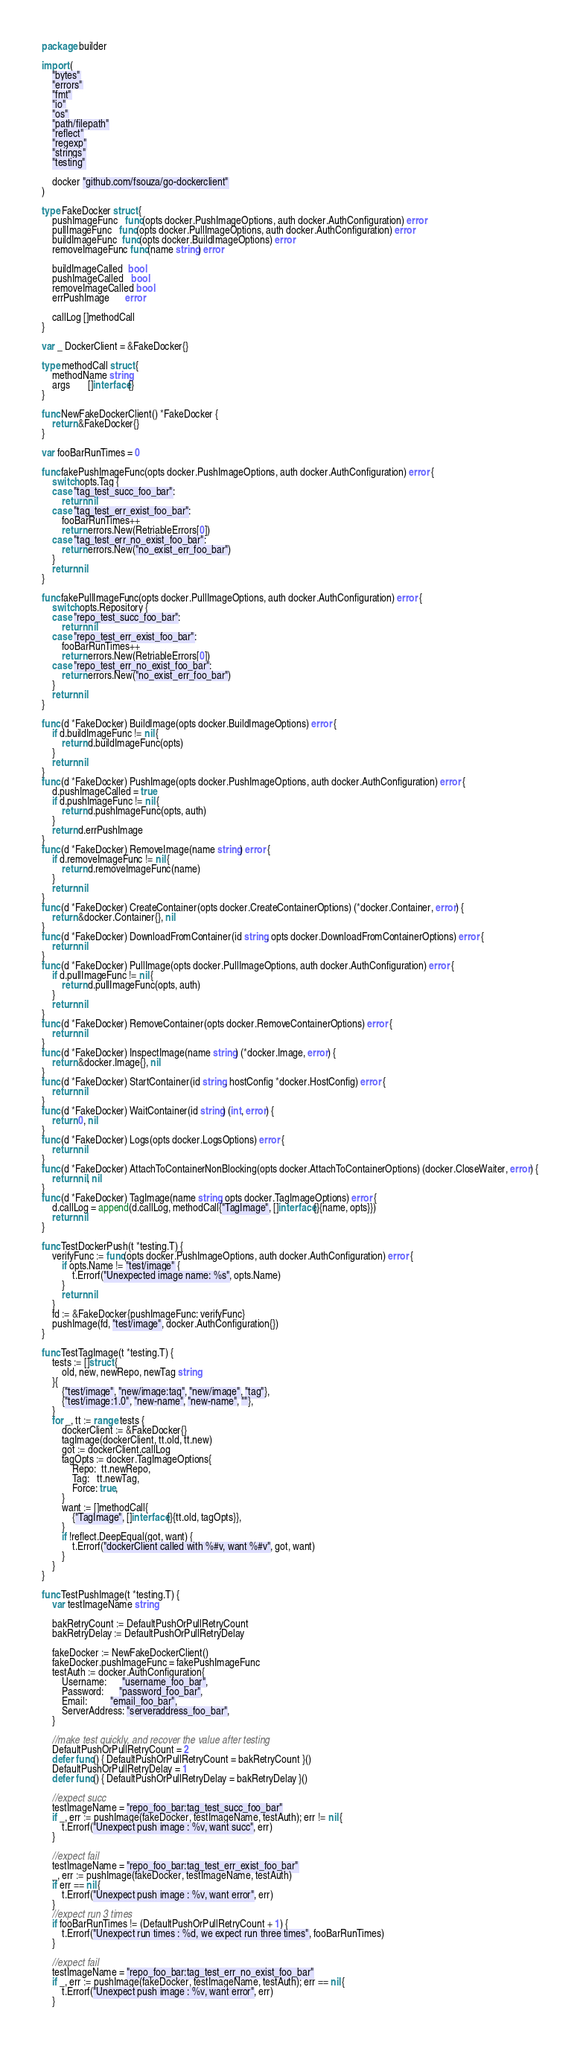Convert code to text. <code><loc_0><loc_0><loc_500><loc_500><_Go_>package builder

import (
	"bytes"
	"errors"
	"fmt"
	"io"
	"os"
	"path/filepath"
	"reflect"
	"regexp"
	"strings"
	"testing"

	docker "github.com/fsouza/go-dockerclient"
)

type FakeDocker struct {
	pushImageFunc   func(opts docker.PushImageOptions, auth docker.AuthConfiguration) error
	pullImageFunc   func(opts docker.PullImageOptions, auth docker.AuthConfiguration) error
	buildImageFunc  func(opts docker.BuildImageOptions) error
	removeImageFunc func(name string) error

	buildImageCalled  bool
	pushImageCalled   bool
	removeImageCalled bool
	errPushImage      error

	callLog []methodCall
}

var _ DockerClient = &FakeDocker{}

type methodCall struct {
	methodName string
	args       []interface{}
}

func NewFakeDockerClient() *FakeDocker {
	return &FakeDocker{}
}

var fooBarRunTimes = 0

func fakePushImageFunc(opts docker.PushImageOptions, auth docker.AuthConfiguration) error {
	switch opts.Tag {
	case "tag_test_succ_foo_bar":
		return nil
	case "tag_test_err_exist_foo_bar":
		fooBarRunTimes++
		return errors.New(RetriableErrors[0])
	case "tag_test_err_no_exist_foo_bar":
		return errors.New("no_exist_err_foo_bar")
	}
	return nil
}

func fakePullImageFunc(opts docker.PullImageOptions, auth docker.AuthConfiguration) error {
	switch opts.Repository {
	case "repo_test_succ_foo_bar":
		return nil
	case "repo_test_err_exist_foo_bar":
		fooBarRunTimes++
		return errors.New(RetriableErrors[0])
	case "repo_test_err_no_exist_foo_bar":
		return errors.New("no_exist_err_foo_bar")
	}
	return nil
}

func (d *FakeDocker) BuildImage(opts docker.BuildImageOptions) error {
	if d.buildImageFunc != nil {
		return d.buildImageFunc(opts)
	}
	return nil
}
func (d *FakeDocker) PushImage(opts docker.PushImageOptions, auth docker.AuthConfiguration) error {
	d.pushImageCalled = true
	if d.pushImageFunc != nil {
		return d.pushImageFunc(opts, auth)
	}
	return d.errPushImage
}
func (d *FakeDocker) RemoveImage(name string) error {
	if d.removeImageFunc != nil {
		return d.removeImageFunc(name)
	}
	return nil
}
func (d *FakeDocker) CreateContainer(opts docker.CreateContainerOptions) (*docker.Container, error) {
	return &docker.Container{}, nil
}
func (d *FakeDocker) DownloadFromContainer(id string, opts docker.DownloadFromContainerOptions) error {
	return nil
}
func (d *FakeDocker) PullImage(opts docker.PullImageOptions, auth docker.AuthConfiguration) error {
	if d.pullImageFunc != nil {
		return d.pullImageFunc(opts, auth)
	}
	return nil
}
func (d *FakeDocker) RemoveContainer(opts docker.RemoveContainerOptions) error {
	return nil
}
func (d *FakeDocker) InspectImage(name string) (*docker.Image, error) {
	return &docker.Image{}, nil
}
func (d *FakeDocker) StartContainer(id string, hostConfig *docker.HostConfig) error {
	return nil
}
func (d *FakeDocker) WaitContainer(id string) (int, error) {
	return 0, nil
}
func (d *FakeDocker) Logs(opts docker.LogsOptions) error {
	return nil
}
func (d *FakeDocker) AttachToContainerNonBlocking(opts docker.AttachToContainerOptions) (docker.CloseWaiter, error) {
	return nil, nil
}
func (d *FakeDocker) TagImage(name string, opts docker.TagImageOptions) error {
	d.callLog = append(d.callLog, methodCall{"TagImage", []interface{}{name, opts}})
	return nil
}

func TestDockerPush(t *testing.T) {
	verifyFunc := func(opts docker.PushImageOptions, auth docker.AuthConfiguration) error {
		if opts.Name != "test/image" {
			t.Errorf("Unexpected image name: %s", opts.Name)
		}
		return nil
	}
	fd := &FakeDocker{pushImageFunc: verifyFunc}
	pushImage(fd, "test/image", docker.AuthConfiguration{})
}

func TestTagImage(t *testing.T) {
	tests := []struct {
		old, new, newRepo, newTag string
	}{
		{"test/image", "new/image:tag", "new/image", "tag"},
		{"test/image:1.0", "new-name", "new-name", ""},
	}
	for _, tt := range tests {
		dockerClient := &FakeDocker{}
		tagImage(dockerClient, tt.old, tt.new)
		got := dockerClient.callLog
		tagOpts := docker.TagImageOptions{
			Repo:  tt.newRepo,
			Tag:   tt.newTag,
			Force: true,
		}
		want := []methodCall{
			{"TagImage", []interface{}{tt.old, tagOpts}},
		}
		if !reflect.DeepEqual(got, want) {
			t.Errorf("dockerClient called with %#v, want %#v", got, want)
		}
	}
}

func TestPushImage(t *testing.T) {
	var testImageName string

	bakRetryCount := DefaultPushOrPullRetryCount
	bakRetryDelay := DefaultPushOrPullRetryDelay

	fakeDocker := NewFakeDockerClient()
	fakeDocker.pushImageFunc = fakePushImageFunc
	testAuth := docker.AuthConfiguration{
		Username:      "username_foo_bar",
		Password:      "password_foo_bar",
		Email:         "email_foo_bar",
		ServerAddress: "serveraddress_foo_bar",
	}

	//make test quickly, and recover the value after testing
	DefaultPushOrPullRetryCount = 2
	defer func() { DefaultPushOrPullRetryCount = bakRetryCount }()
	DefaultPushOrPullRetryDelay = 1
	defer func() { DefaultPushOrPullRetryDelay = bakRetryDelay }()

	//expect succ
	testImageName = "repo_foo_bar:tag_test_succ_foo_bar"
	if _, err := pushImage(fakeDocker, testImageName, testAuth); err != nil {
		t.Errorf("Unexpect push image : %v, want succ", err)
	}

	//expect fail
	testImageName = "repo_foo_bar:tag_test_err_exist_foo_bar"
	_, err := pushImage(fakeDocker, testImageName, testAuth)
	if err == nil {
		t.Errorf("Unexpect push image : %v, want error", err)
	}
	//expect run 3 times
	if fooBarRunTimes != (DefaultPushOrPullRetryCount + 1) {
		t.Errorf("Unexpect run times : %d, we expect run three times", fooBarRunTimes)
	}

	//expect fail
	testImageName = "repo_foo_bar:tag_test_err_no_exist_foo_bar"
	if _, err := pushImage(fakeDocker, testImageName, testAuth); err == nil {
		t.Errorf("Unexpect push image : %v, want error", err)
	}</code> 